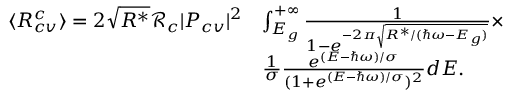Convert formula to latex. <formula><loc_0><loc_0><loc_500><loc_500>\begin{array} { r l } { \langle R _ { c v } ^ { c } \rangle = 2 \sqrt { R ^ { * } } \mathcal { R } _ { c } | P _ { c v } | ^ { 2 } } & { \int _ { E _ { g } } ^ { + \infty } \frac { 1 } { 1 - e ^ { - 2 \pi \sqrt { R ^ { * } / ( \hbar { \omega } - E _ { g } ) } } } \times } \\ & { \frac { 1 } { \sigma } \frac { e ^ { ( E - \hbar { \omega } ) / \sigma } } { ( 1 + e ^ { ( E - \hbar { \omega } ) / \sigma } ) ^ { 2 } } d E . } \end{array}</formula> 